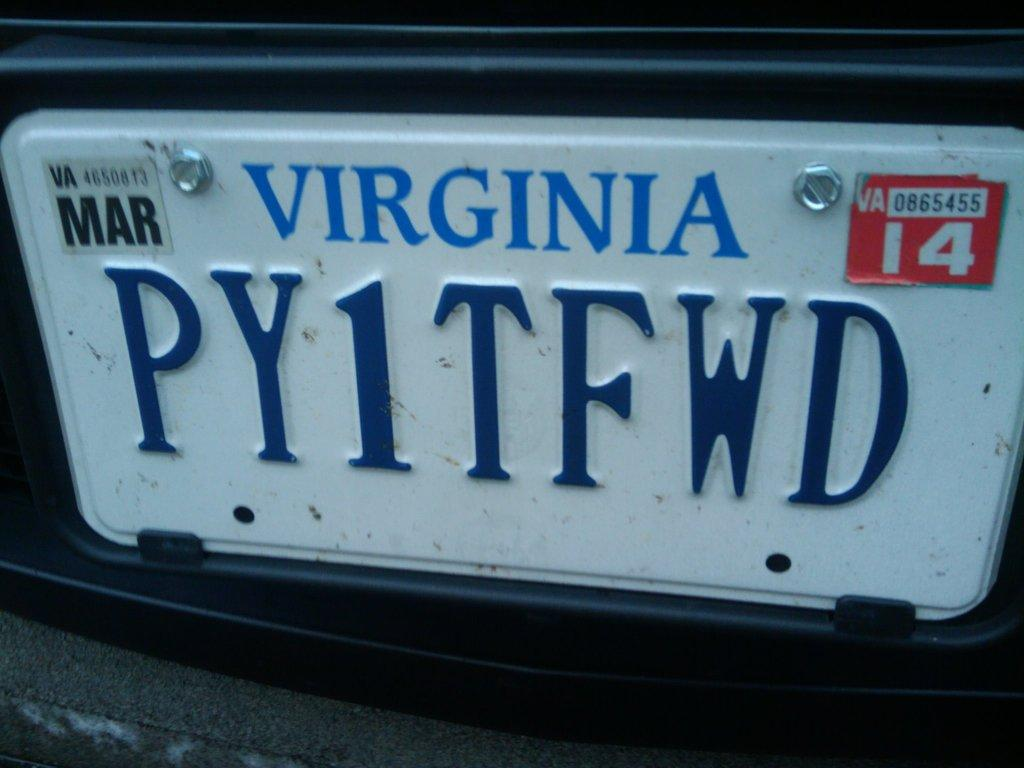<image>
Describe the image concisely. A close up showing that Virginia plate number PY1TFWD expires in March. 